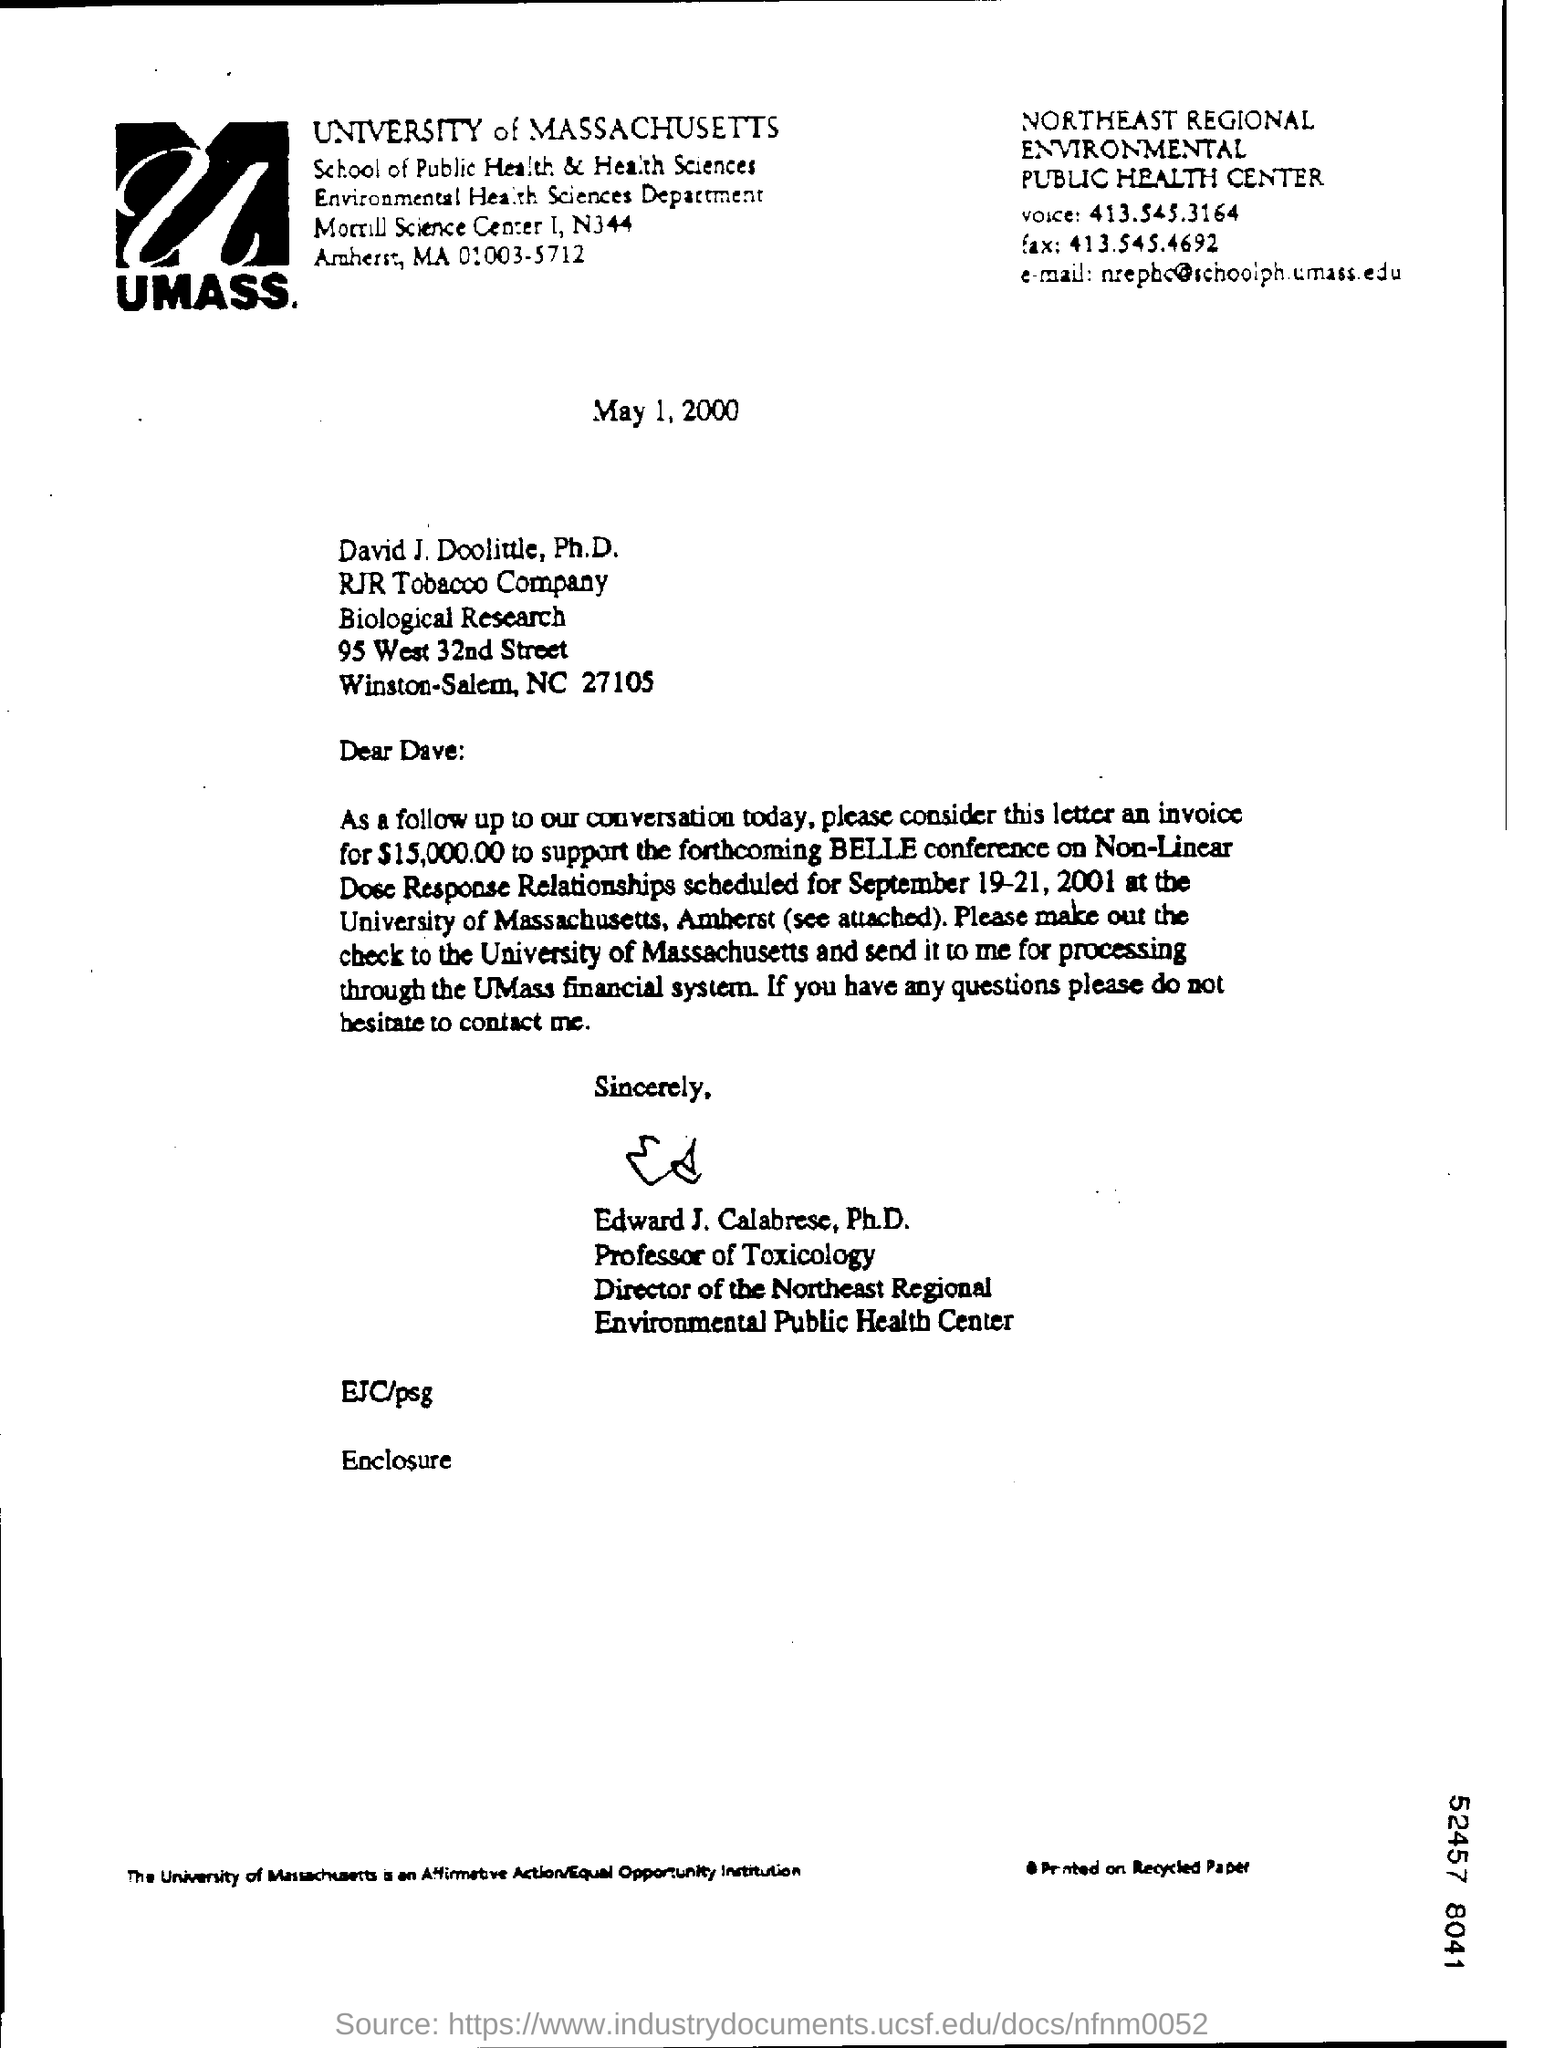What is the date of the document?
Provide a succinct answer. May 1, 2000. What is the salutation of this letter?
Your response must be concise. Dear Dave. Who is this  addressed to?
Offer a very short reply. David J. Doolittle. What is the invoice amount?
Your answer should be very brief. $15,000.00. Who wrote this letter?
Make the answer very short. Edward J. Calabrese, Ph.D. 